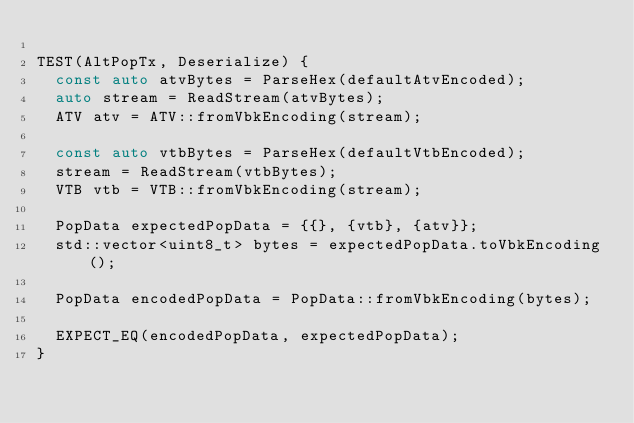<code> <loc_0><loc_0><loc_500><loc_500><_C++_>
TEST(AltPopTx, Deserialize) {
  const auto atvBytes = ParseHex(defaultAtvEncoded);
  auto stream = ReadStream(atvBytes);
  ATV atv = ATV::fromVbkEncoding(stream);

  const auto vtbBytes = ParseHex(defaultVtbEncoded);
  stream = ReadStream(vtbBytes);
  VTB vtb = VTB::fromVbkEncoding(stream);

  PopData expectedPopData = {{}, {vtb}, {atv}};
  std::vector<uint8_t> bytes = expectedPopData.toVbkEncoding();

  PopData encodedPopData = PopData::fromVbkEncoding(bytes);

  EXPECT_EQ(encodedPopData, expectedPopData);
}
</code> 